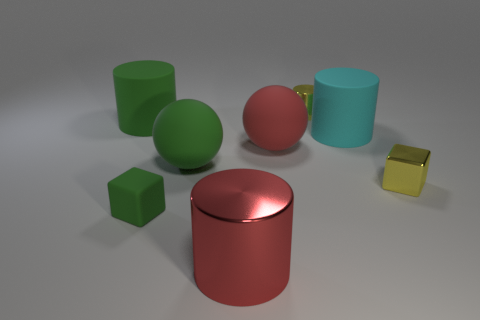Subtract all large red cylinders. How many cylinders are left? 3 Subtract all red cylinders. How many cylinders are left? 3 Add 2 big red balls. How many objects exist? 10 Subtract all cubes. How many objects are left? 6 Subtract all blue cylinders. Subtract all yellow spheres. How many cylinders are left? 4 Subtract all red balls. Subtract all tiny matte things. How many objects are left? 6 Add 4 tiny yellow shiny blocks. How many tiny yellow shiny blocks are left? 5 Add 5 metallic cylinders. How many metallic cylinders exist? 7 Subtract 0 red blocks. How many objects are left? 8 